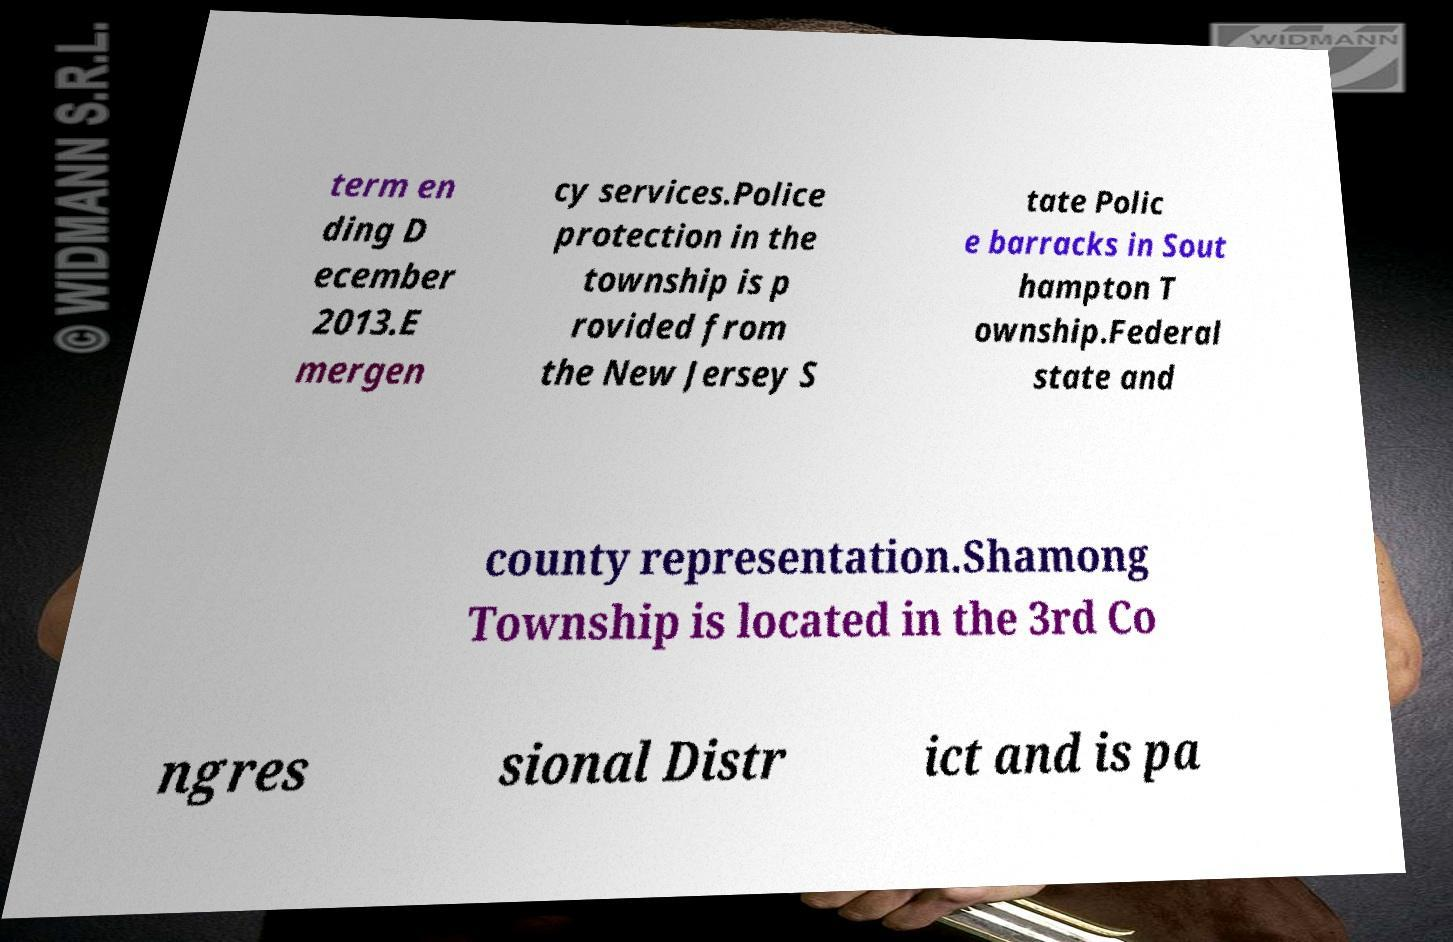Please identify and transcribe the text found in this image. term en ding D ecember 2013.E mergen cy services.Police protection in the township is p rovided from the New Jersey S tate Polic e barracks in Sout hampton T ownship.Federal state and county representation.Shamong Township is located in the 3rd Co ngres sional Distr ict and is pa 